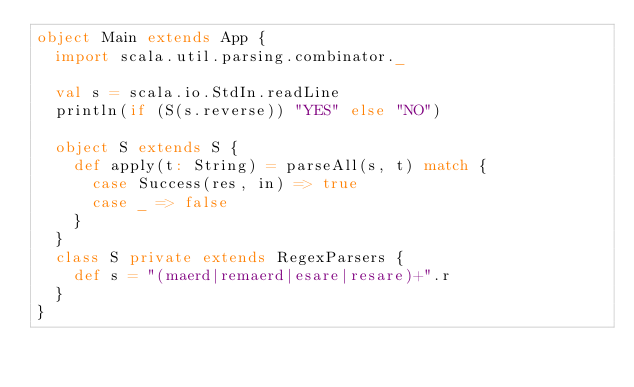Convert code to text. <code><loc_0><loc_0><loc_500><loc_500><_Scala_>object Main extends App {
  import scala.util.parsing.combinator._

  val s = scala.io.StdIn.readLine
  println(if (S(s.reverse)) "YES" else "NO")

  object S extends S {
    def apply(t: String) = parseAll(s, t) match {
      case Success(res, in) => true
      case _ => false
    }
  }
  class S private extends RegexParsers {
    def s = "(maerd|remaerd|esare|resare)+".r
  }
}</code> 